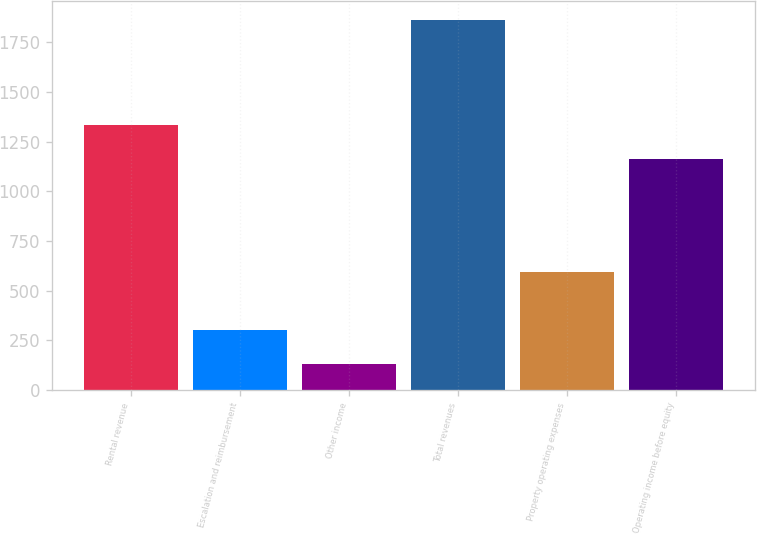Convert chart to OTSL. <chart><loc_0><loc_0><loc_500><loc_500><bar_chart><fcel>Rental revenue<fcel>Escalation and reimbursement<fcel>Other income<fcel>Total revenues<fcel>Property operating expenses<fcel>Operating income before equity<nl><fcel>1335.57<fcel>303.67<fcel>130.3<fcel>1864<fcel>594.5<fcel>1162.2<nl></chart> 